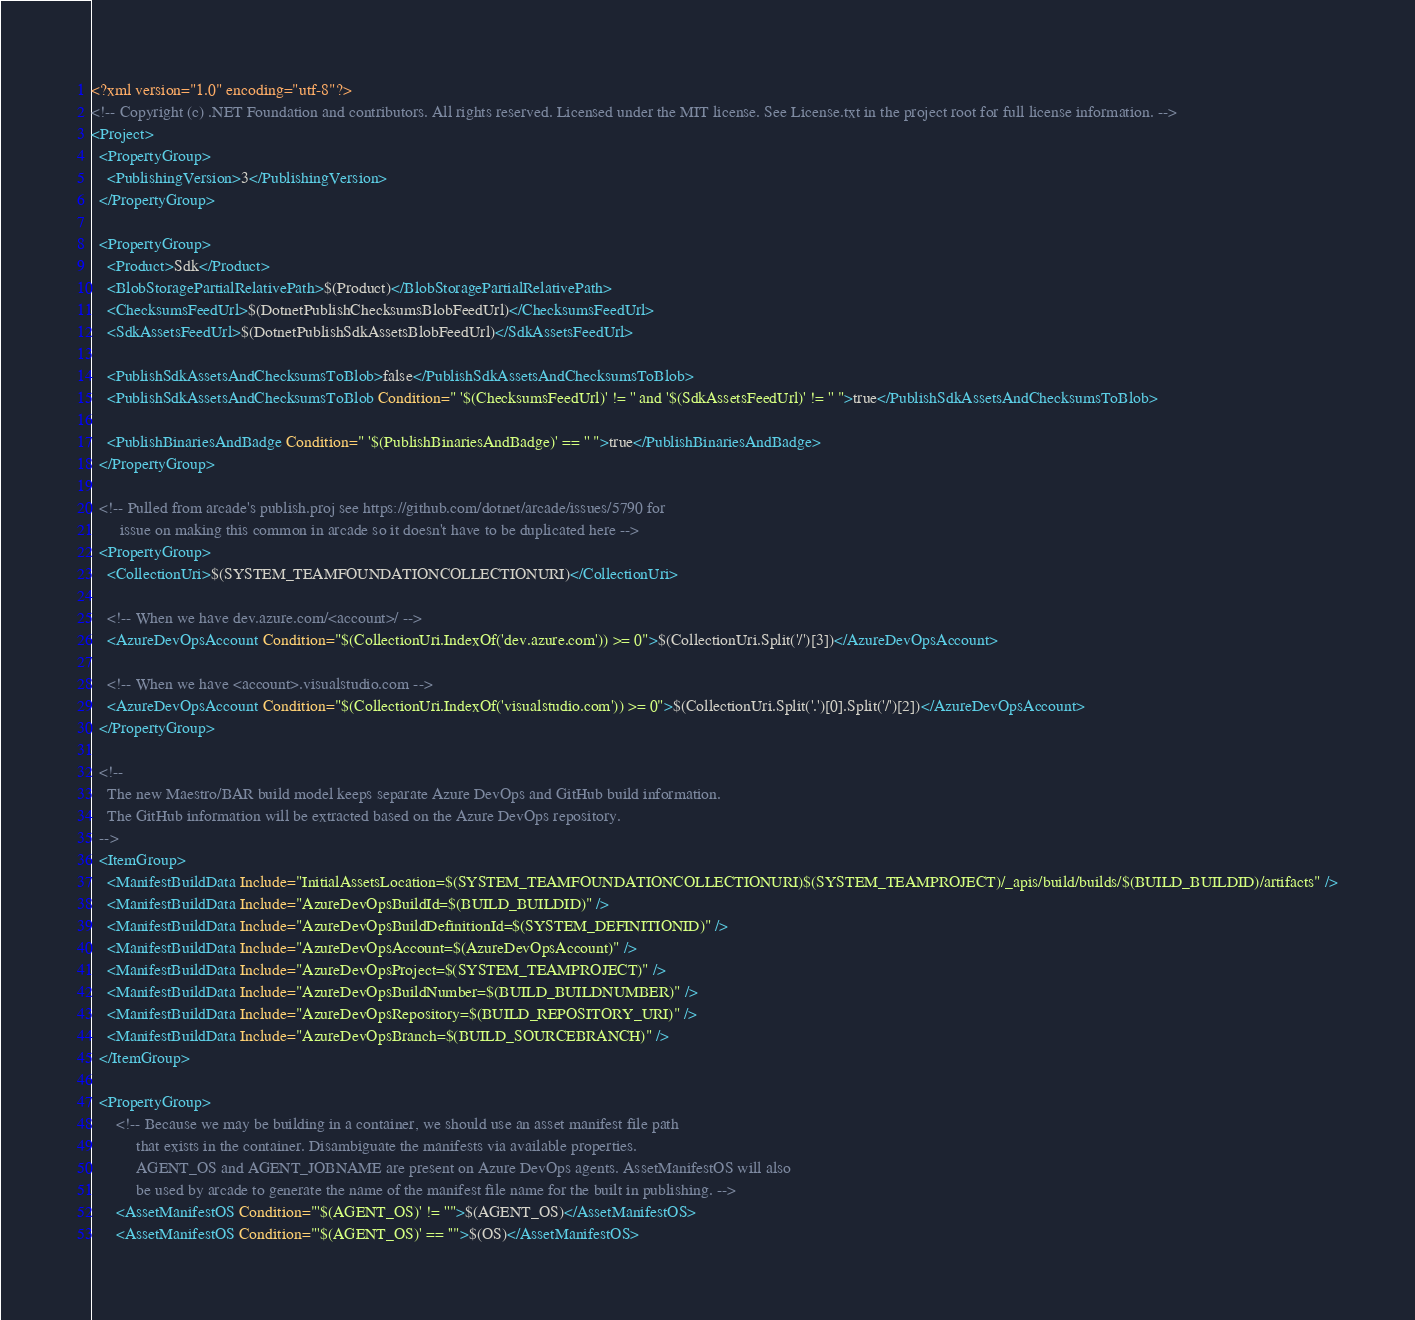<code> <loc_0><loc_0><loc_500><loc_500><_XML_><?xml version="1.0" encoding="utf-8"?>
<!-- Copyright (c) .NET Foundation and contributors. All rights reserved. Licensed under the MIT license. See License.txt in the project root for full license information. -->
<Project>
  <PropertyGroup>
    <PublishingVersion>3</PublishingVersion>
  </PropertyGroup>

  <PropertyGroup>
    <Product>Sdk</Product>
    <BlobStoragePartialRelativePath>$(Product)</BlobStoragePartialRelativePath>
    <ChecksumsFeedUrl>$(DotnetPublishChecksumsBlobFeedUrl)</ChecksumsFeedUrl>
    <SdkAssetsFeedUrl>$(DotnetPublishSdkAssetsBlobFeedUrl)</SdkAssetsFeedUrl>

    <PublishSdkAssetsAndChecksumsToBlob>false</PublishSdkAssetsAndChecksumsToBlob>
    <PublishSdkAssetsAndChecksumsToBlob Condition=" '$(ChecksumsFeedUrl)' != '' and '$(SdkAssetsFeedUrl)' != '' ">true</PublishSdkAssetsAndChecksumsToBlob>

    <PublishBinariesAndBadge Condition=" '$(PublishBinariesAndBadge)' == '' ">true</PublishBinariesAndBadge>
  </PropertyGroup>

  <!-- Pulled from arcade's publish.proj see https://github.com/dotnet/arcade/issues/5790 for
       issue on making this common in arcade so it doesn't have to be duplicated here -->
  <PropertyGroup>
    <CollectionUri>$(SYSTEM_TEAMFOUNDATIONCOLLECTIONURI)</CollectionUri>

    <!-- When we have dev.azure.com/<account>/ -->
    <AzureDevOpsAccount Condition="$(CollectionUri.IndexOf('dev.azure.com')) >= 0">$(CollectionUri.Split('/')[3])</AzureDevOpsAccount>

    <!-- When we have <account>.visualstudio.com -->
    <AzureDevOpsAccount Condition="$(CollectionUri.IndexOf('visualstudio.com')) >= 0">$(CollectionUri.Split('.')[0].Split('/')[2])</AzureDevOpsAccount>
  </PropertyGroup>

  <!--
    The new Maestro/BAR build model keeps separate Azure DevOps and GitHub build information.
    The GitHub information will be extracted based on the Azure DevOps repository.
  -->
  <ItemGroup>
    <ManifestBuildData Include="InitialAssetsLocation=$(SYSTEM_TEAMFOUNDATIONCOLLECTIONURI)$(SYSTEM_TEAMPROJECT)/_apis/build/builds/$(BUILD_BUILDID)/artifacts" />
    <ManifestBuildData Include="AzureDevOpsBuildId=$(BUILD_BUILDID)" />
    <ManifestBuildData Include="AzureDevOpsBuildDefinitionId=$(SYSTEM_DEFINITIONID)" />
    <ManifestBuildData Include="AzureDevOpsAccount=$(AzureDevOpsAccount)" />
    <ManifestBuildData Include="AzureDevOpsProject=$(SYSTEM_TEAMPROJECT)" />
    <ManifestBuildData Include="AzureDevOpsBuildNumber=$(BUILD_BUILDNUMBER)" />
    <ManifestBuildData Include="AzureDevOpsRepository=$(BUILD_REPOSITORY_URI)" />
    <ManifestBuildData Include="AzureDevOpsBranch=$(BUILD_SOURCEBRANCH)" />
  </ItemGroup>

  <PropertyGroup>
      <!-- Because we may be building in a container, we should use an asset manifest file path
           that exists in the container. Disambiguate the manifests via available properties.
           AGENT_OS and AGENT_JOBNAME are present on Azure DevOps agents. AssetManifestOS will also
           be used by arcade to generate the name of the manifest file name for the built in publishing. -->
      <AssetManifestOS Condition="'$(AGENT_OS)' != ''">$(AGENT_OS)</AssetManifestOS>
      <AssetManifestOS Condition="'$(AGENT_OS)' == ''">$(OS)</AssetManifestOS></code> 